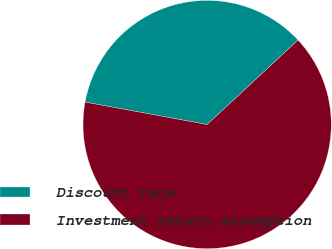Convert chart. <chart><loc_0><loc_0><loc_500><loc_500><pie_chart><fcel>Discount rate<fcel>Investment return assumption<nl><fcel>35.19%<fcel>64.81%<nl></chart> 